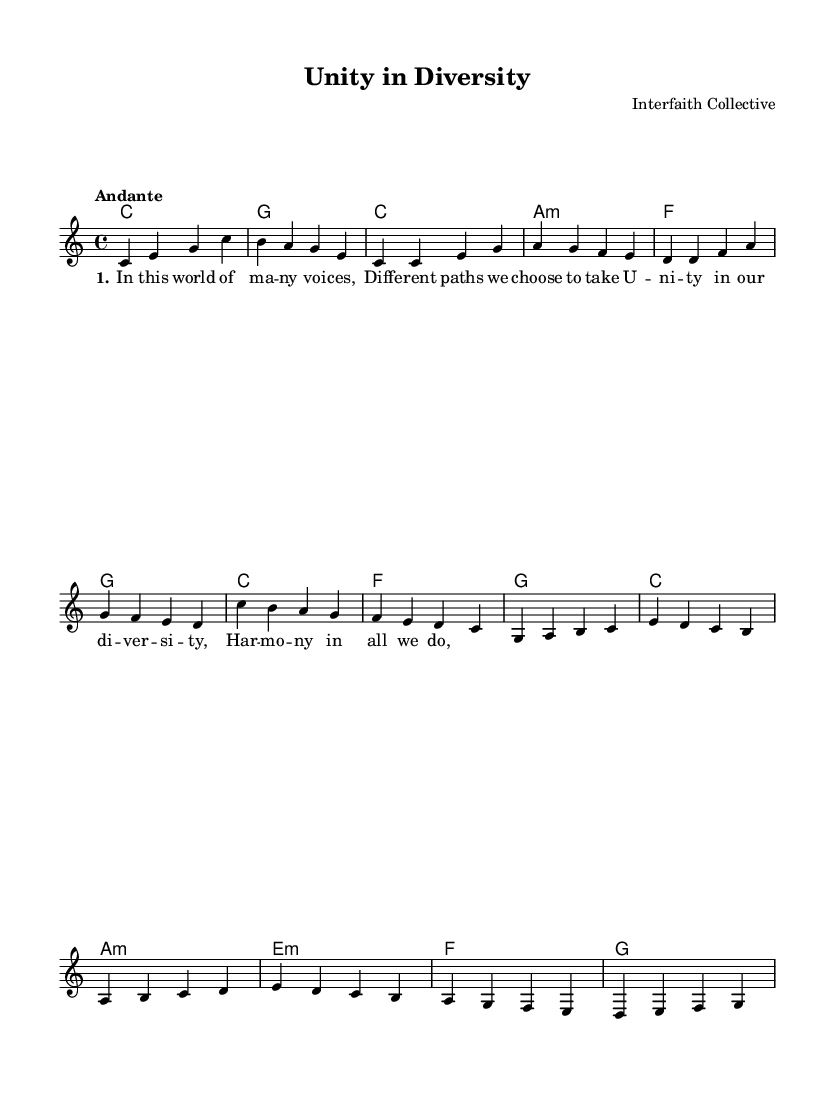What is the key signature of this music? The key signature is indicated at the beginning of the sheet music, where C major is specified. C major has no sharps or flats.
Answer: C major What is the time signature of this piece? The time signature appears at the beginning of the sheet music, specified as 4/4. This means there are four beats in each measure, and the quarter note gets one beat.
Answer: 4/4 What is the tempo marking for this composition? The tempo is noted in the score as "Andante," which is a term that indicates a moderate pace in music.
Answer: Andante How many measures are in the intro section? The intro section consists of two measures, as can be counted from the music notation directly.
Answer: 2 measures What is the main theme of the chorus? The chorus lyrics emphasize "Unity in our diversity," as indicated in the lyrics section, which captures the essence of the song's message.
Answer: Unity in our diversity How does the bridge differ from the verse in key modulations? The bridge section shifts to a minor chord progression with a specific focus on A minor, E minor, and F major, contrasting with the verse which primarily uses C major and A minor. This change provides emotional depth and variation.
Answer: A minor 